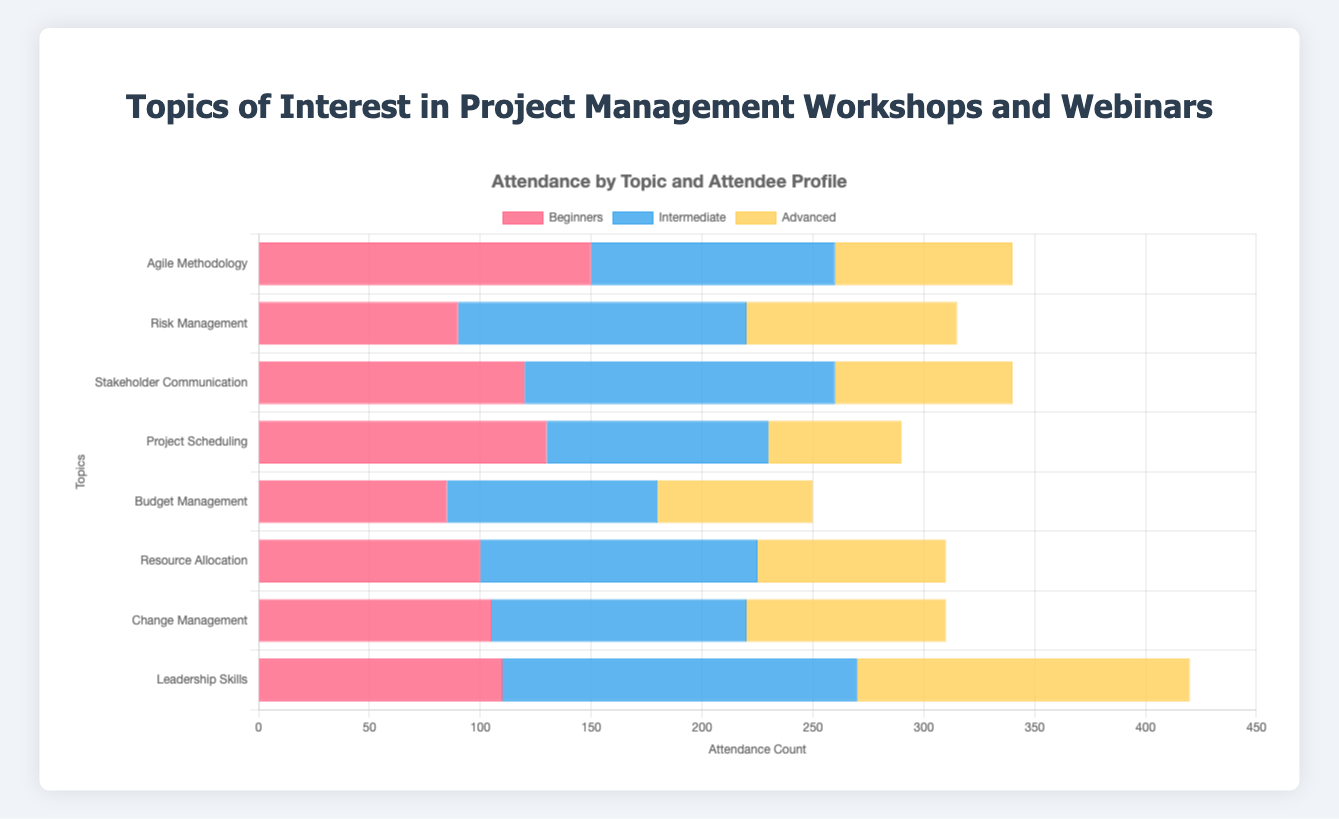Which topic had the highest attendance among beginners? From the grouped bar chart, we can directly see that the topic "Agile Methodology" has the tallest bar in the category of beginners, indicating it has the highest attendance.
Answer: Agile Methodology Which attendee profile shows the most interest in Leadership Skills? Comparing the bars for Leadership Skills across the three profiles, the tallest bar is for Intermediate attendees.
Answer: Intermediate What is the total attendance for Risk Management across all attendee profiles? Add the attendance counts for Risk Management for beginners, intermediate, and advanced profiles: 90 + 130 + 95 = 315.
Answer: 315 How does the attendance for Project Scheduling among Advanced attendees compare to that among Beginners? Comparing the horizontal bars for Project Scheduling, Beginners have an attendance count of 130, while Advanced attendees have a count of 60. Thus, Beginners have more attendance.
Answer: Beginners have more attendance Which topic had the least interest among Advanced attendees? Checking the height of the bars in the Advanced attendees category, the shortest bar corresponds to "Project Scheduling" with an attendance count of 60.
Answer: Project Scheduling What is the difference in attendance between Beginners and Intermediate attendees in Resource Allocation? The bars for Resource Allocation show Beginners with 100 attendees and Intermediate with 125 attendees. The difference is 125 - 100 = 25.
Answer: 25 What is the average attendance for Change Management across all profiles? Sum the attendance counts for Change Management for all profiles: 105 (Beginners) + 115 (Intermediate) + 90 (Advanced) = 310, then divide by 3 (the number of profiles) 310 / 3 ≈ 103.33.
Answer: 103.33 How many more attendees are there for Leadership Skills compared to Budget Management among Advanced attendees? The attendance count for Leadership Skills in Advanced is 150 and for Budget Management is 70. The difference is 150 - 70 = 80.
Answer: 80 Which topic has exactly equal attendance for Beginners and Advanced profiles? By checking the lengths of the bars, "Stakeholder Communication" has equal attendance for Beginners and Advanced profiles, each with a count of 80.
Answer: Stakeholder Communication Combining the attendance for all profiles, which topic had the highest total attendance? Sum the attendance counts for each topic across all profiles and compare. Agile Methodology: 150+110+80=340. Risk Management: 90+130+95=315. Stakeholder Communication: 120+140+80=340. Project Scheduling: 130+100+60=290. Budget Management: 85+95+70=250. Resource Allocation: 100+125+85=310. Change Management: 105+115+90=310. Leadership Skills: 110+160+150=420. The highest total is for Leadership Skills with 420.
Answer: Leadership Skills 